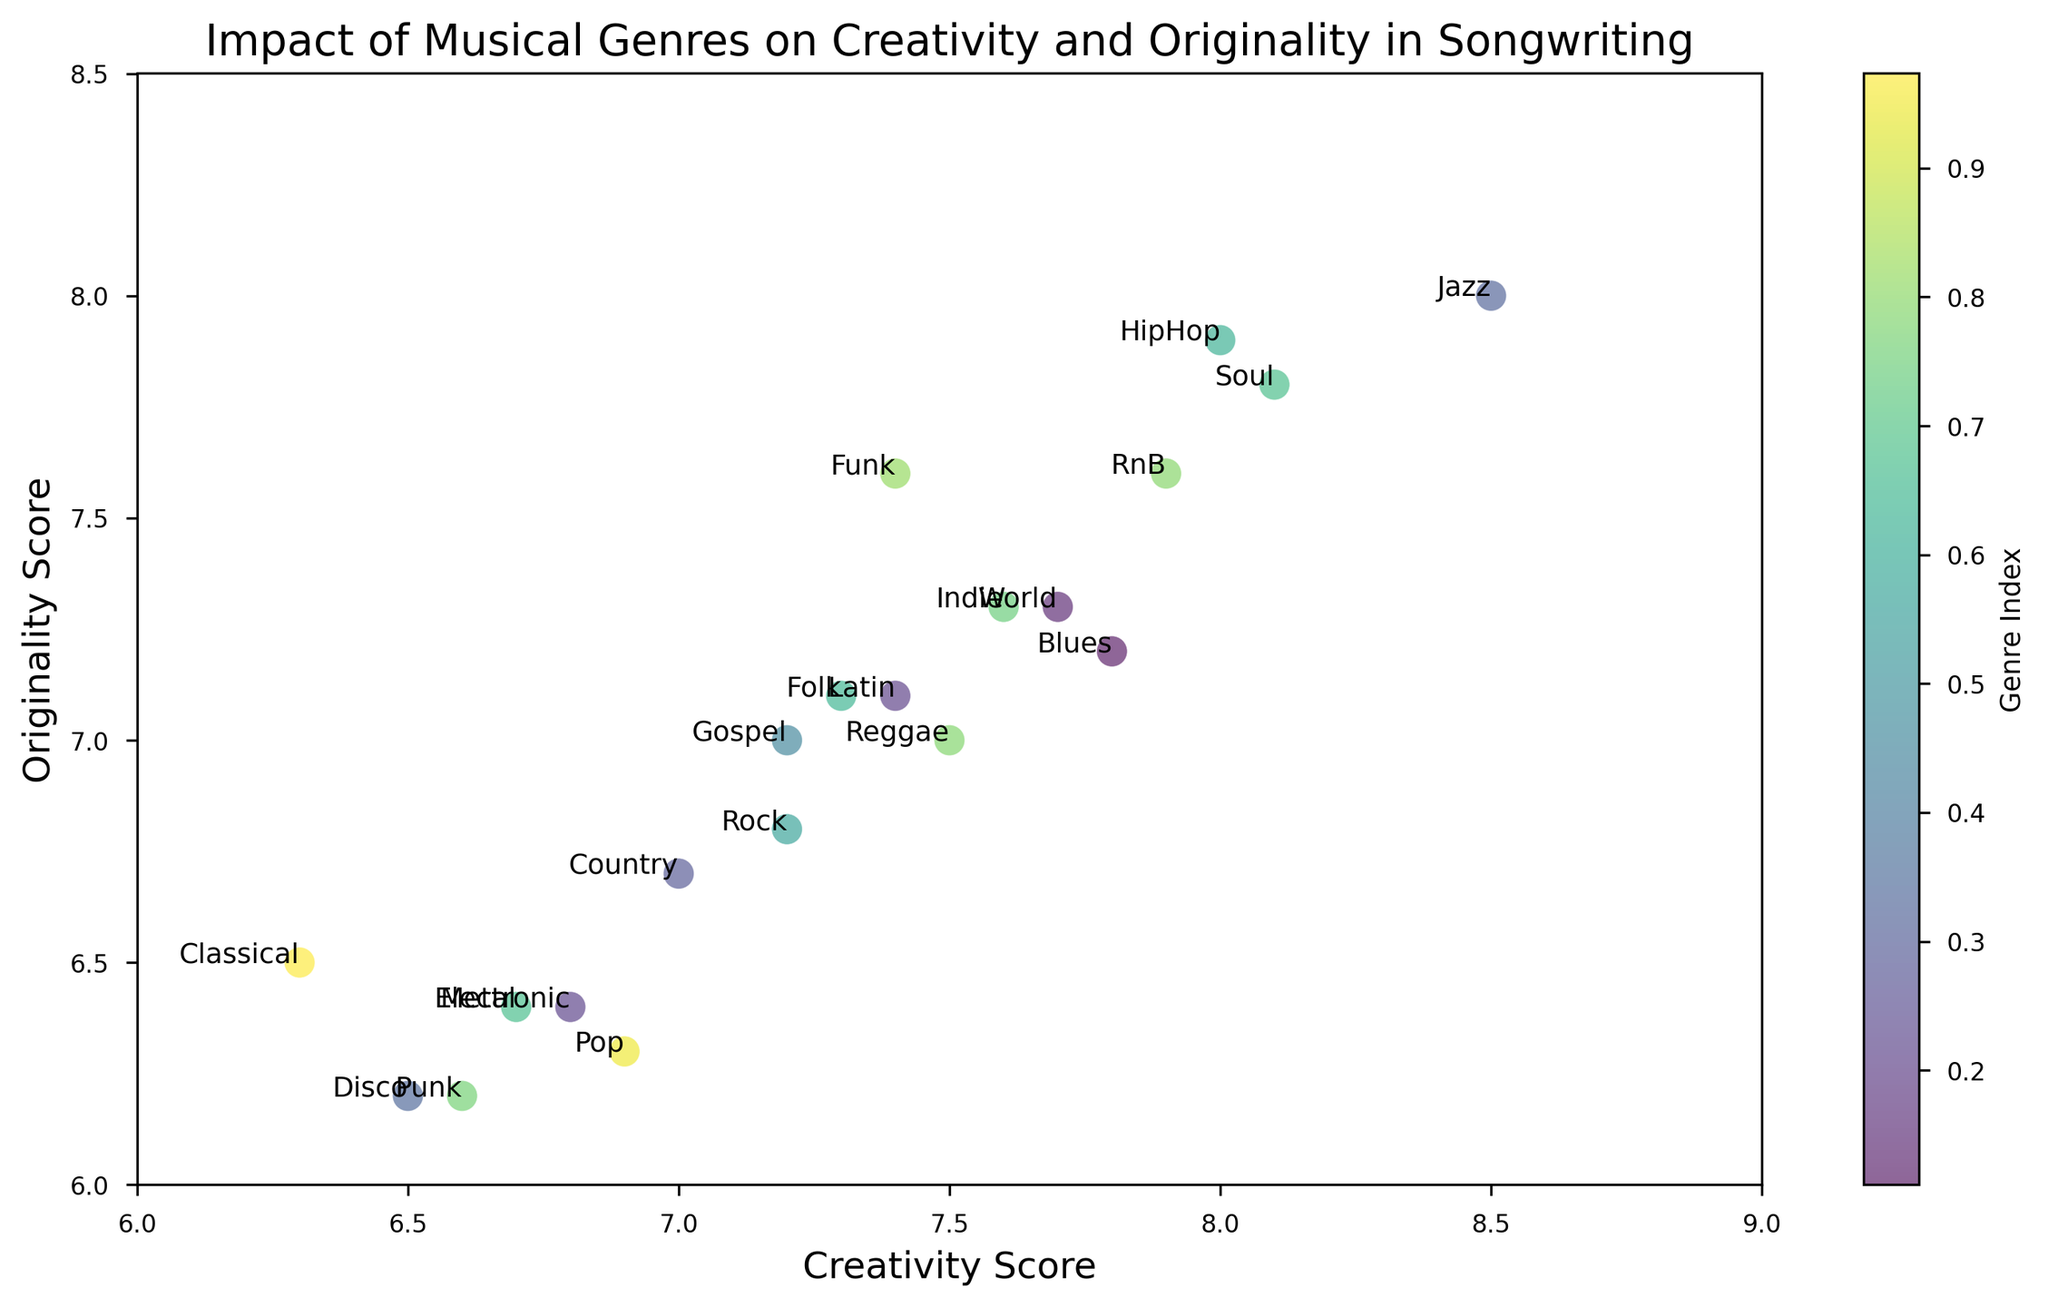What's the genre with the highest creativity score? Look for the genre with the highest value on the x-axis (Creativity Score). Jazz has the highest creativity score of 8.5.
Answer: Jazz Which genre has both creativity and originality scores below 7? Check the points below 7 on both x-axis (Creativity Score) and y-axis (Originality Score). Only Disco falls into this category with scores 6.5 and 6.2 respectively.
Answer: Disco Which genres have an originality score higher than or equal to 7 but less than 7.5? Identify the genres positioned between y-values 7 and 7.5. Genres meeting this criterion are Reggae, Folk, Indie, Latin, and Country.
Answer: Reggae, Folk, Indie, Latin, Country Which genre has the closest values for creativity and originality scores? Compare the proximity of the x-axis (Creativity Score) and y-axis (Originality Score) coordinates. Classical has values 6.3 and 6.5, making the difference 0.2.
Answer: Classical What's the average creativity score for genres with originality scores above 7.5? Identify genres with originality scores above 7.5: Jazz, HipHop, RnB, Soul, Funk. Compute their creativity score average: (8.5 + 8.0 + 7.9 + 8.1 + 7.4) / 5 = 7.98.
Answer: 7.98 Which genre has the lowest originality score with creativity score above 7.0? Among points above 7.0 on the x-axis (Creativity), find the one with the lowest y-axis (Originality) score. Pop has originality score 6.3 with creativity of 6.9; however, a creativity score above 7.0 restricts this to Country with originality 6.7.
Answer: Country What is the difference in originality scores between the genre with the highest and the genre with the lowest creativity score? The genre with the highest creativity score is Jazz (8.5), and the genre with the lowest creativity score is Classical (6.3). Their originality scores are 8.0 and 6.5 respectively. The difference is 8.0 - 6.5 = 1.5.
Answer: 1.5 Which genre has the highest originality score among those with creativity scores below 7.0? Find points below 7.0 on the x-axis, then locate the highest y-axis value. Metal has creativity score 6.7 and highest originality score 6.4 among them.
Answer: Metal What is the average originality score for the genres labeled Punk and Gospel? Add the originality scores for Punk (6.2) and Gospel (7.0), and then divide by 2. (6.2 + 7.0) / 2 = 6.6.
Answer: 6.6 Which genres have exactly equal creativity and originality scores? Look at the plot for points where the x and y values match exactly. There are no genres with exactly equal scores.
Answer: None 